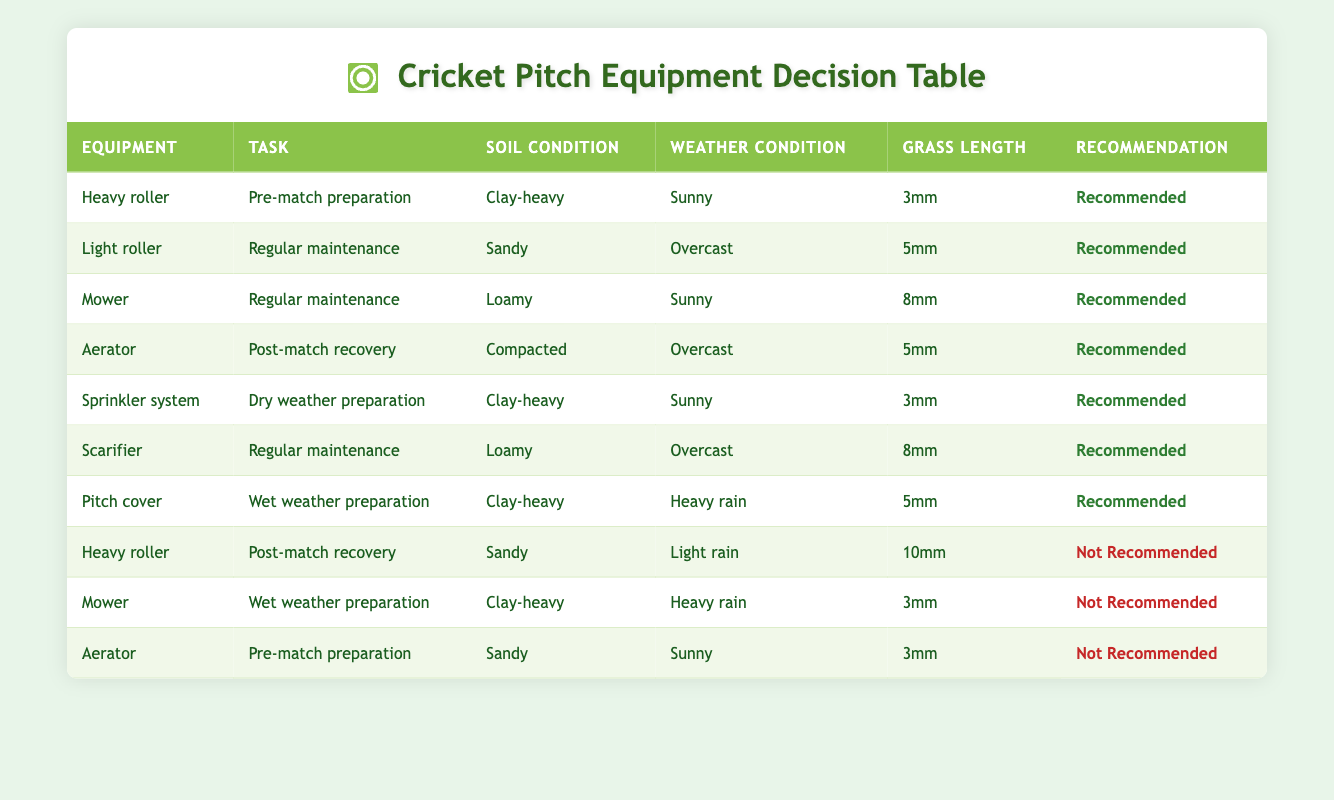What equipment is recommended for wet weather preparation? In the table, the task "Wet weather preparation" has only one piece of equipment listed as recommended, which is "Pitch cover."
Answer: Pitch cover Which soil condition is associated with the use of a light roller? The table indicates that the light roller is used for the task "Regular maintenance" under the soil condition "Sandy."
Answer: Sandy Is a heavy roller recommended during post-match recovery for sandy soil in light rain? The table states that the heavy roller for post-match recovery with sandy soil during light rain is marked as "Not Recommended."
Answer: No What tasks require the use of an aerator? The table shows that the aerator is recommended for "Post-match recovery" (Compacted soil, Overcast weather, 5mm grass length) and is not recommended for "Pre-match preparation" (Sandy soil, Sunny weather, 3mm grass length).
Answer: Post-match recovery How many pieces of equipment are recommended for dry weather preparation? The only piece of equipment recommended for the task "Dry weather preparation" is "Sprinkler system," thus there is a total of one equipment.
Answer: 1 Are there any tasks where mowing is not recommended? Yes, the table shows that mowing is not recommended for "Wet weather preparation" when the soil is clay-heavy, and it is heavy rain.
Answer: Yes What is the weather condition and grass length when the heavy roller is recommended for pre-match preparation? According to the table, for pre-match preparation, the heavy roller is recommended under sunny weather with a grass length of 3mm on clay-heavy soil.
Answer: Sunny, 3mm Can an aerator be used for pre-match preparation in sandy soil during sunny weather? The table indicates that using an aerator for pre-match preparation in sandy soil during sunny weather is "Not Recommended."
Answer: No What equipment is recommended for regular maintenance on loamy soil? The table lists both the mower and the scarifier as recommended pieces of equipment for regular maintenance on loamy soil, for sunny and overcast weather respectively.
Answer: Mower, Scarifier 